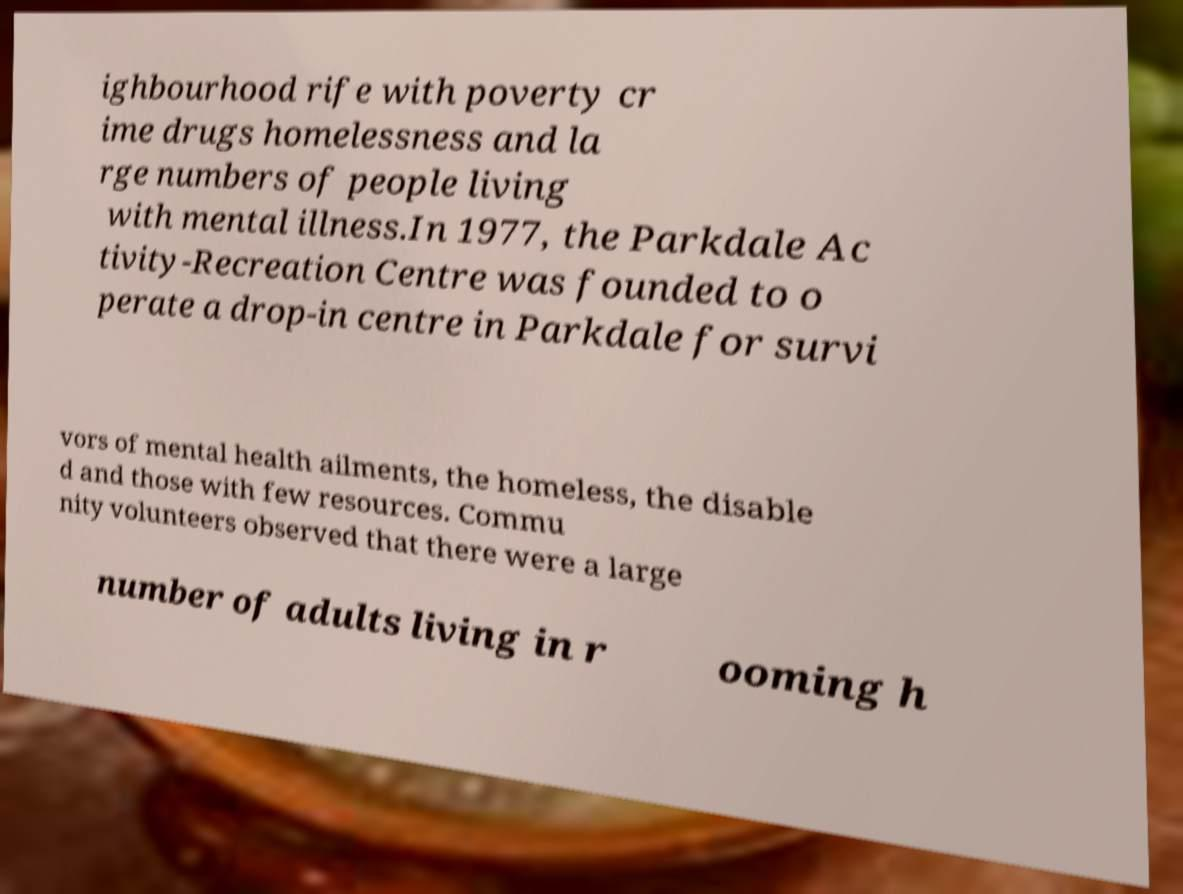Can you accurately transcribe the text from the provided image for me? ighbourhood rife with poverty cr ime drugs homelessness and la rge numbers of people living with mental illness.In 1977, the Parkdale Ac tivity-Recreation Centre was founded to o perate a drop-in centre in Parkdale for survi vors of mental health ailments, the homeless, the disable d and those with few resources. Commu nity volunteers observed that there were a large number of adults living in r ooming h 